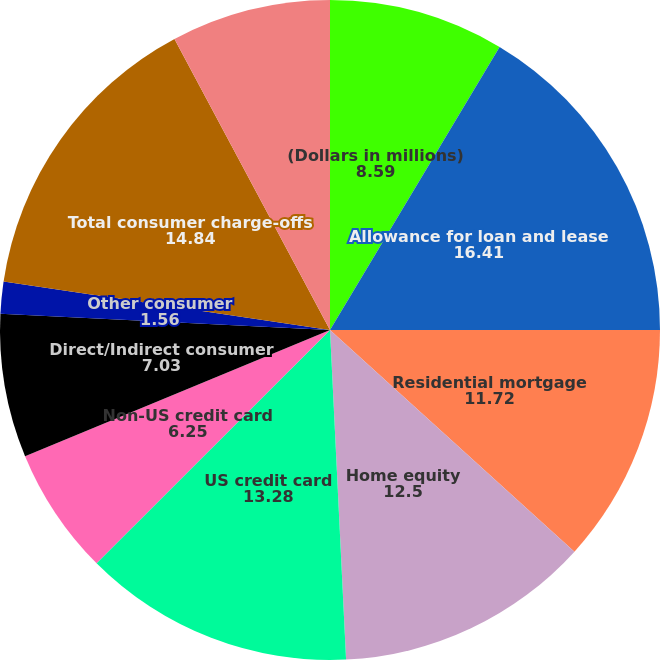Convert chart. <chart><loc_0><loc_0><loc_500><loc_500><pie_chart><fcel>(Dollars in millions)<fcel>Allowance for loan and lease<fcel>Residential mortgage<fcel>Home equity<fcel>US credit card<fcel>Non-US credit card<fcel>Direct/Indirect consumer<fcel>Other consumer<fcel>Total consumer charge-offs<fcel>US commercial (2)<nl><fcel>8.59%<fcel>16.41%<fcel>11.72%<fcel>12.5%<fcel>13.28%<fcel>6.25%<fcel>7.03%<fcel>1.56%<fcel>14.84%<fcel>7.81%<nl></chart> 